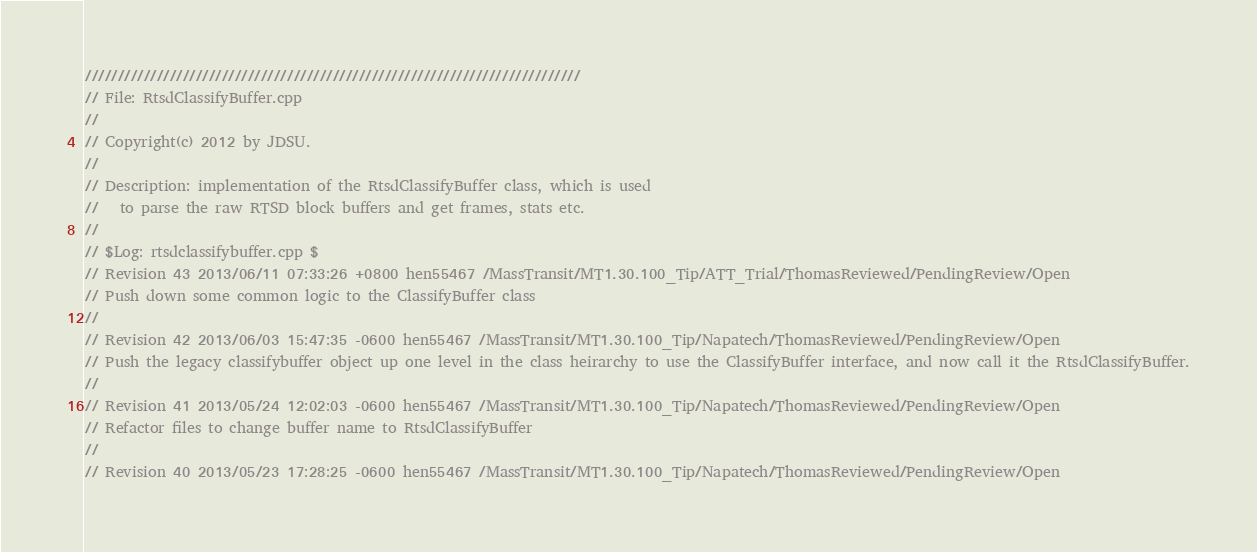<code> <loc_0><loc_0><loc_500><loc_500><_C++_>////////////////////////////////////////////////////////////////////////////
// File: RtsdClassifyBuffer.cpp
//
// Copyright(c) 2012 by JDSU.
//
// Description: implementation of the RtsdClassifyBuffer class, which is used
//   to parse the raw RTSD block buffers and get frames, stats etc.
//
// $Log: rtsdclassifybuffer.cpp $
// Revision 43 2013/06/11 07:33:26 +0800 hen55467 /MassTransit/MT1.30.100_Tip/ATT_Trial/ThomasReviewed/PendingReview/Open
// Push down some common logic to the ClassifyBuffer class
// 
// Revision 42 2013/06/03 15:47:35 -0600 hen55467 /MassTransit/MT1.30.100_Tip/Napatech/ThomasReviewed/PendingReview/Open
// Push the legacy classifybuffer object up one level in the class heirarchy to use the ClassifyBuffer interface, and now call it the RtsdClassifyBuffer.
// 
// Revision 41 2013/05/24 12:02:03 -0600 hen55467 /MassTransit/MT1.30.100_Tip/Napatech/ThomasReviewed/PendingReview/Open
// Refactor files to change buffer name to RtsdClassifyBuffer
// 
// Revision 40 2013/05/23 17:28:25 -0600 hen55467 /MassTransit/MT1.30.100_Tip/Napatech/ThomasReviewed/PendingReview/Open</code> 